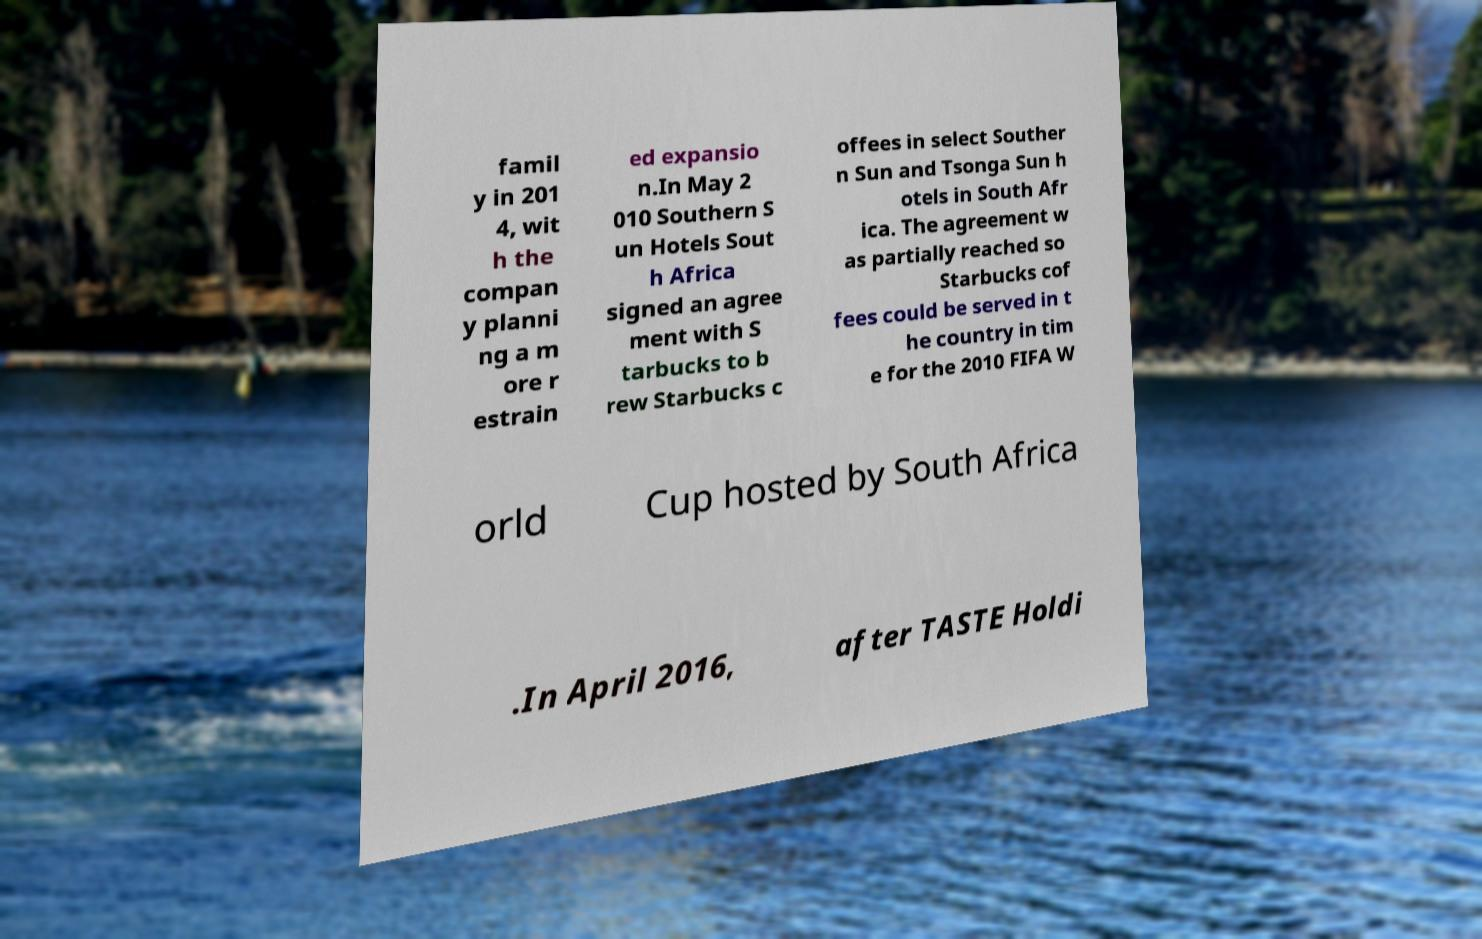There's text embedded in this image that I need extracted. Can you transcribe it verbatim? famil y in 201 4, wit h the compan y planni ng a m ore r estrain ed expansio n.In May 2 010 Southern S un Hotels Sout h Africa signed an agree ment with S tarbucks to b rew Starbucks c offees in select Souther n Sun and Tsonga Sun h otels in South Afr ica. The agreement w as partially reached so Starbucks cof fees could be served in t he country in tim e for the 2010 FIFA W orld Cup hosted by South Africa .In April 2016, after TASTE Holdi 